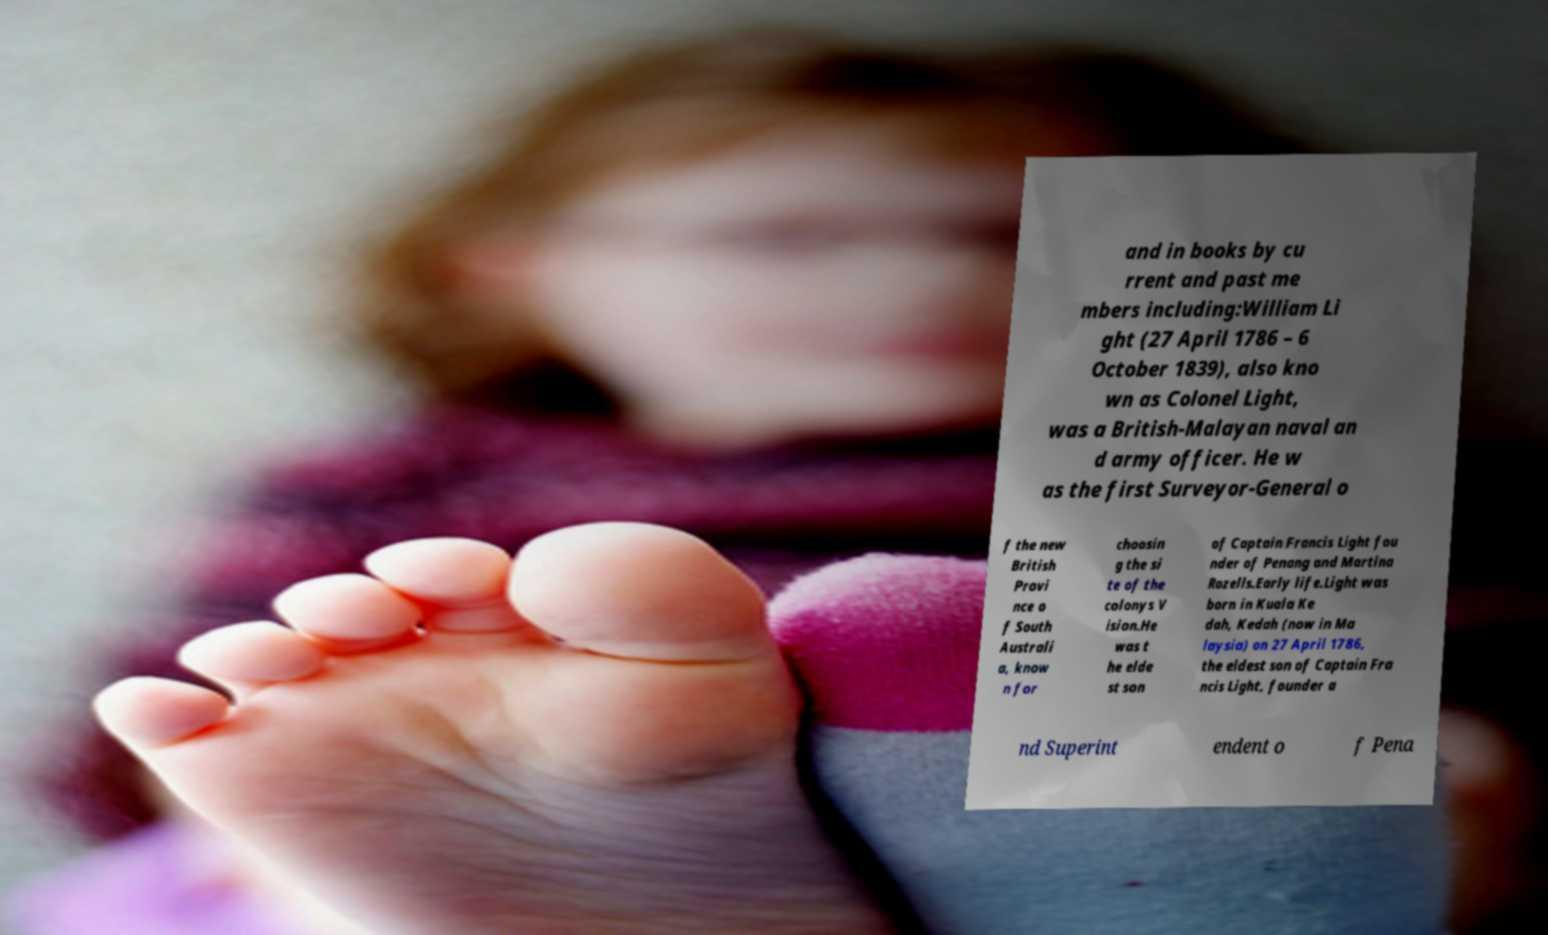Could you assist in decoding the text presented in this image and type it out clearly? and in books by cu rrent and past me mbers including:William Li ght (27 April 1786 – 6 October 1839), also kno wn as Colonel Light, was a British-Malayan naval an d army officer. He w as the first Surveyor-General o f the new British Provi nce o f South Australi a, know n for choosin g the si te of the colonys V ision.He was t he elde st son of Captain Francis Light fou nder of Penang and Martina Rozells.Early life.Light was born in Kuala Ke dah, Kedah (now in Ma laysia) on 27 April 1786, the eldest son of Captain Fra ncis Light, founder a nd Superint endent o f Pena 